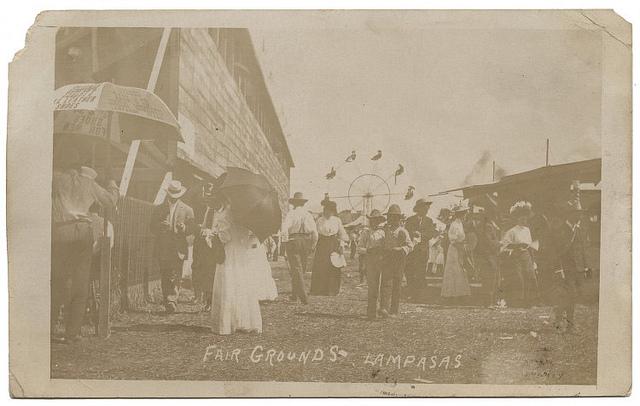How many umbrellas are there?
Be succinct. 2. Is the photo in black and white?
Keep it brief. Yes. Is this a digitally created image?
Write a very short answer. No. How many heart shapes are in this picture?
Keep it brief. 0. What does it say at the bottom of the photo?
Give a very brief answer. Fairgrounds lampasas. 